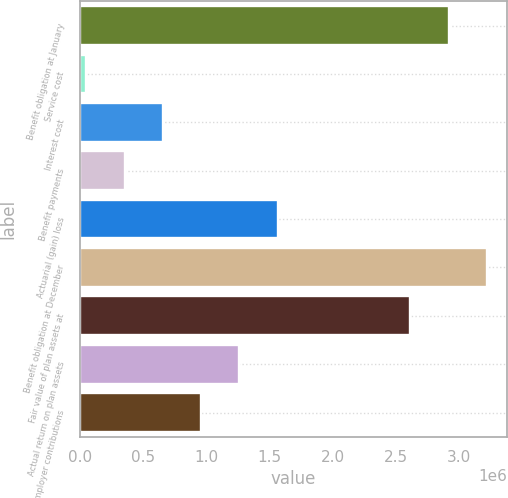Convert chart to OTSL. <chart><loc_0><loc_0><loc_500><loc_500><bar_chart><fcel>Benefit obligation at January<fcel>Service cost<fcel>Interest cost<fcel>Benefit payments<fcel>Actuarial (gain) loss<fcel>Benefit obligation at December<fcel>Fair value of plan assets at<fcel>Actual return on plan assets<fcel>Employer contributions<nl><fcel>2.91796e+06<fcel>53080<fcel>658194<fcel>355637<fcel>1.56586e+06<fcel>3.22052e+06<fcel>2.6154e+06<fcel>1.26331e+06<fcel>960750<nl></chart> 